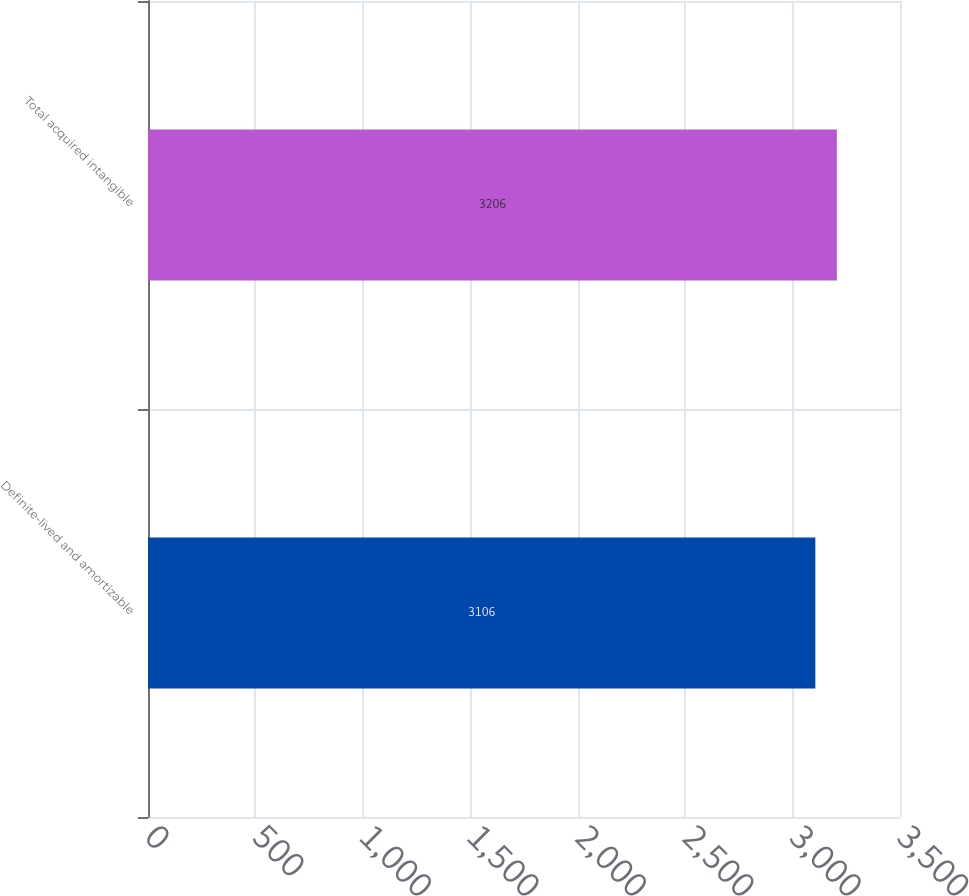Convert chart. <chart><loc_0><loc_0><loc_500><loc_500><bar_chart><fcel>Definite-lived and amortizable<fcel>Total acquired intangible<nl><fcel>3106<fcel>3206<nl></chart> 